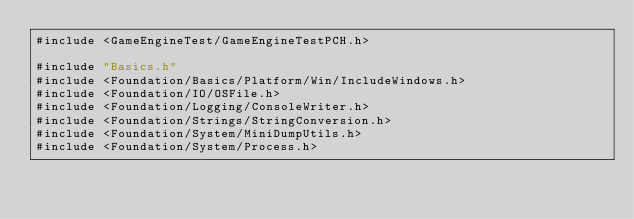<code> <loc_0><loc_0><loc_500><loc_500><_C++_>#include <GameEngineTest/GameEngineTestPCH.h>

#include "Basics.h"
#include <Foundation/Basics/Platform/Win/IncludeWindows.h>
#include <Foundation/IO/OSFile.h>
#include <Foundation/Logging/ConsoleWriter.h>
#include <Foundation/Strings/StringConversion.h>
#include <Foundation/System/MiniDumpUtils.h>
#include <Foundation/System/Process.h></code> 